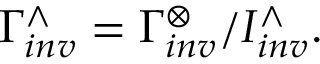<formula> <loc_0><loc_0><loc_500><loc_500>\Gamma _ { i n v } ^ { \wedge } = \Gamma _ { i n v } ^ { \otimes } / I _ { i n v } ^ { \wedge } .</formula> 